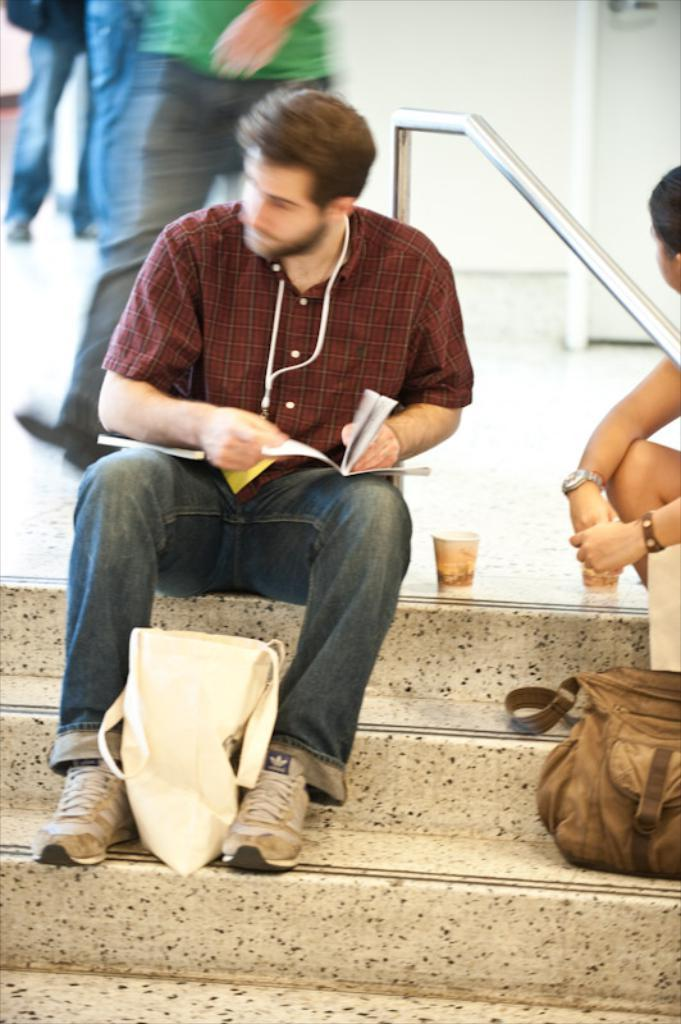What objects can be seen in the image? There are bags and a cup in the image. What are the persons in the image doing? Two persons are sitting on the stairs. Can you describe anything visible in the background? In the background, there are legs of persons visible. What type of stone can be seen in the image? There is no stone present in the image. What flavor of mint is being consumed by the persons in the image? There is no mint visible or mentioned in the image. 